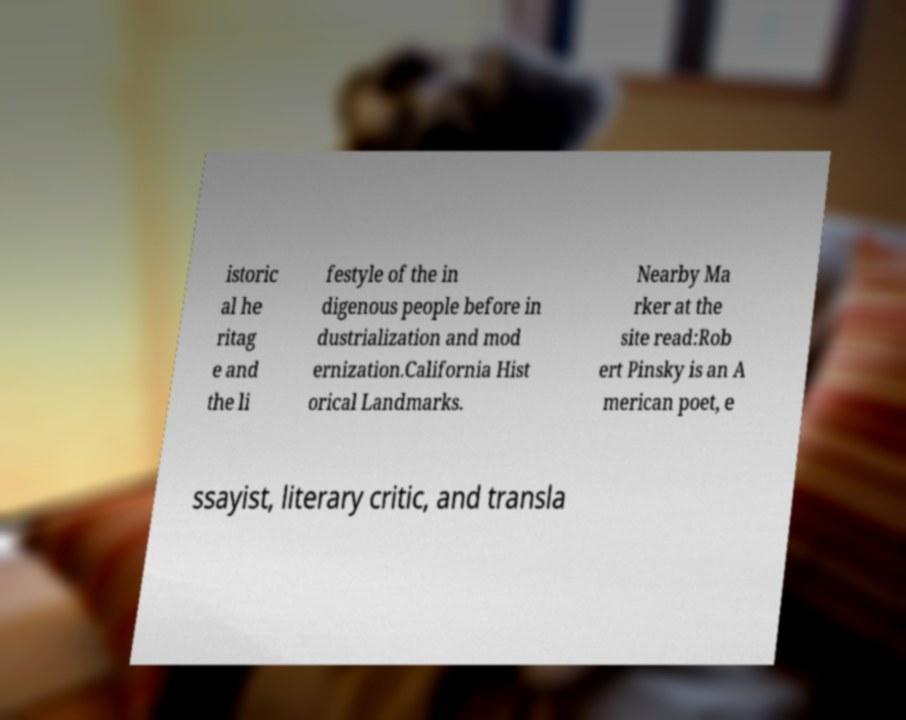Please identify and transcribe the text found in this image. istoric al he ritag e and the li festyle of the in digenous people before in dustrialization and mod ernization.California Hist orical Landmarks. Nearby Ma rker at the site read:Rob ert Pinsky is an A merican poet, e ssayist, literary critic, and transla 